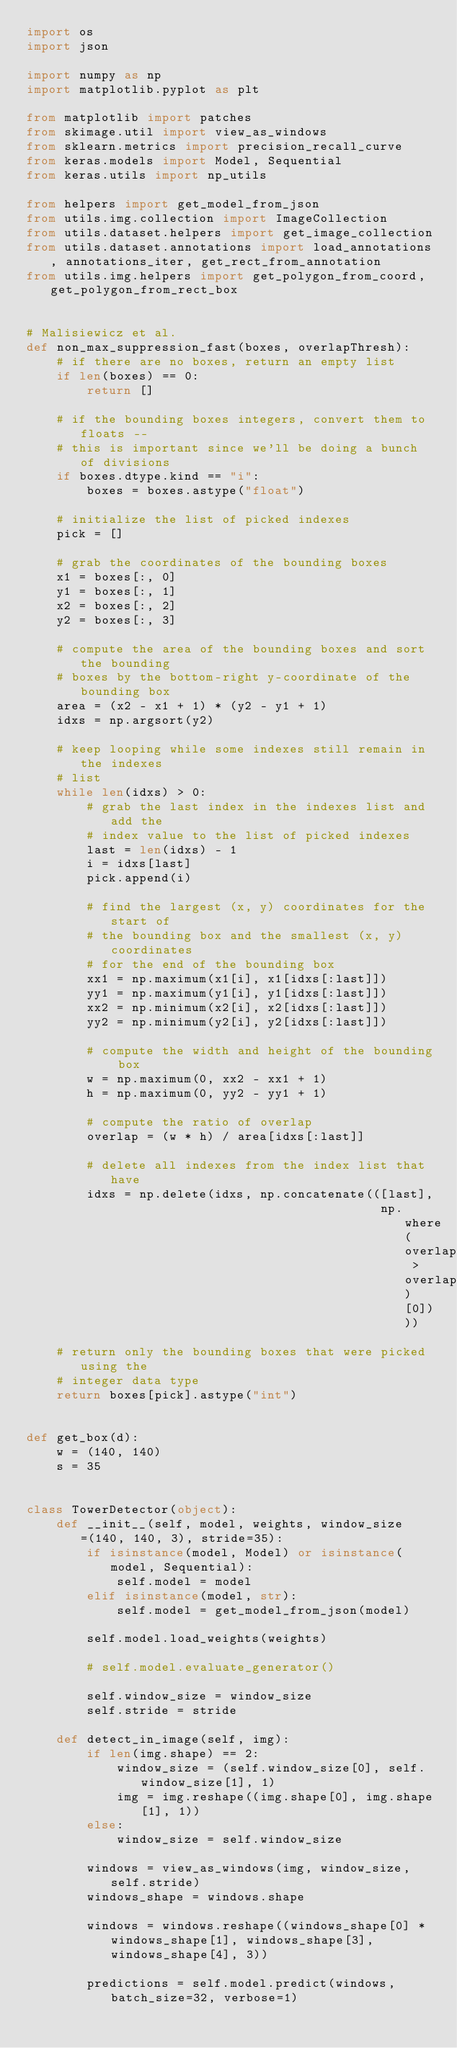<code> <loc_0><loc_0><loc_500><loc_500><_Python_>import os
import json

import numpy as np
import matplotlib.pyplot as plt

from matplotlib import patches
from skimage.util import view_as_windows
from sklearn.metrics import precision_recall_curve
from keras.models import Model, Sequential
from keras.utils import np_utils

from helpers import get_model_from_json
from utils.img.collection import ImageCollection
from utils.dataset.helpers import get_image_collection
from utils.dataset.annotations import load_annotations, annotations_iter, get_rect_from_annotation
from utils.img.helpers import get_polygon_from_coord, get_polygon_from_rect_box


# Malisiewicz et al.
def non_max_suppression_fast(boxes, overlapThresh):
    # if there are no boxes, return an empty list
    if len(boxes) == 0:
        return []

    # if the bounding boxes integers, convert them to floats --
    # this is important since we'll be doing a bunch of divisions
    if boxes.dtype.kind == "i":
        boxes = boxes.astype("float")

    # initialize the list of picked indexes
    pick = []

    # grab the coordinates of the bounding boxes
    x1 = boxes[:, 0]
    y1 = boxes[:, 1]
    x2 = boxes[:, 2]
    y2 = boxes[:, 3]

    # compute the area of the bounding boxes and sort the bounding
    # boxes by the bottom-right y-coordinate of the bounding box
    area = (x2 - x1 + 1) * (y2 - y1 + 1)
    idxs = np.argsort(y2)

    # keep looping while some indexes still remain in the indexes
    # list
    while len(idxs) > 0:
        # grab the last index in the indexes list and add the
        # index value to the list of picked indexes
        last = len(idxs) - 1
        i = idxs[last]
        pick.append(i)

        # find the largest (x, y) coordinates for the start of
        # the bounding box and the smallest (x, y) coordinates
        # for the end of the bounding box
        xx1 = np.maximum(x1[i], x1[idxs[:last]])
        yy1 = np.maximum(y1[i], y1[idxs[:last]])
        xx2 = np.minimum(x2[i], x2[idxs[:last]])
        yy2 = np.minimum(y2[i], y2[idxs[:last]])

        # compute the width and height of the bounding box
        w = np.maximum(0, xx2 - xx1 + 1)
        h = np.maximum(0, yy2 - yy1 + 1)

        # compute the ratio of overlap
        overlap = (w * h) / area[idxs[:last]]

        # delete all indexes from the index list that have
        idxs = np.delete(idxs, np.concatenate(([last],
                                               np.where(overlap > overlapThresh)[0])))

    # return only the bounding boxes that were picked using the
    # integer data type
    return boxes[pick].astype("int")


def get_box(d):
    w = (140, 140)
    s = 35


class TowerDetector(object):
    def __init__(self, model, weights, window_size=(140, 140, 3), stride=35):
        if isinstance(model, Model) or isinstance(model, Sequential):
            self.model = model
        elif isinstance(model, str):
            self.model = get_model_from_json(model)

        self.model.load_weights(weights)

        # self.model.evaluate_generator()

        self.window_size = window_size
        self.stride = stride

    def detect_in_image(self, img):
        if len(img.shape) == 2:
            window_size = (self.window_size[0], self.window_size[1], 1)
            img = img.reshape((img.shape[0], img.shape[1], 1))
        else:
            window_size = self.window_size

        windows = view_as_windows(img, window_size, self.stride)
        windows_shape = windows.shape

        windows = windows.reshape((windows_shape[0] * windows_shape[1], windows_shape[3], windows_shape[4], 3))

        predictions = self.model.predict(windows, batch_size=32, verbose=1)
</code> 